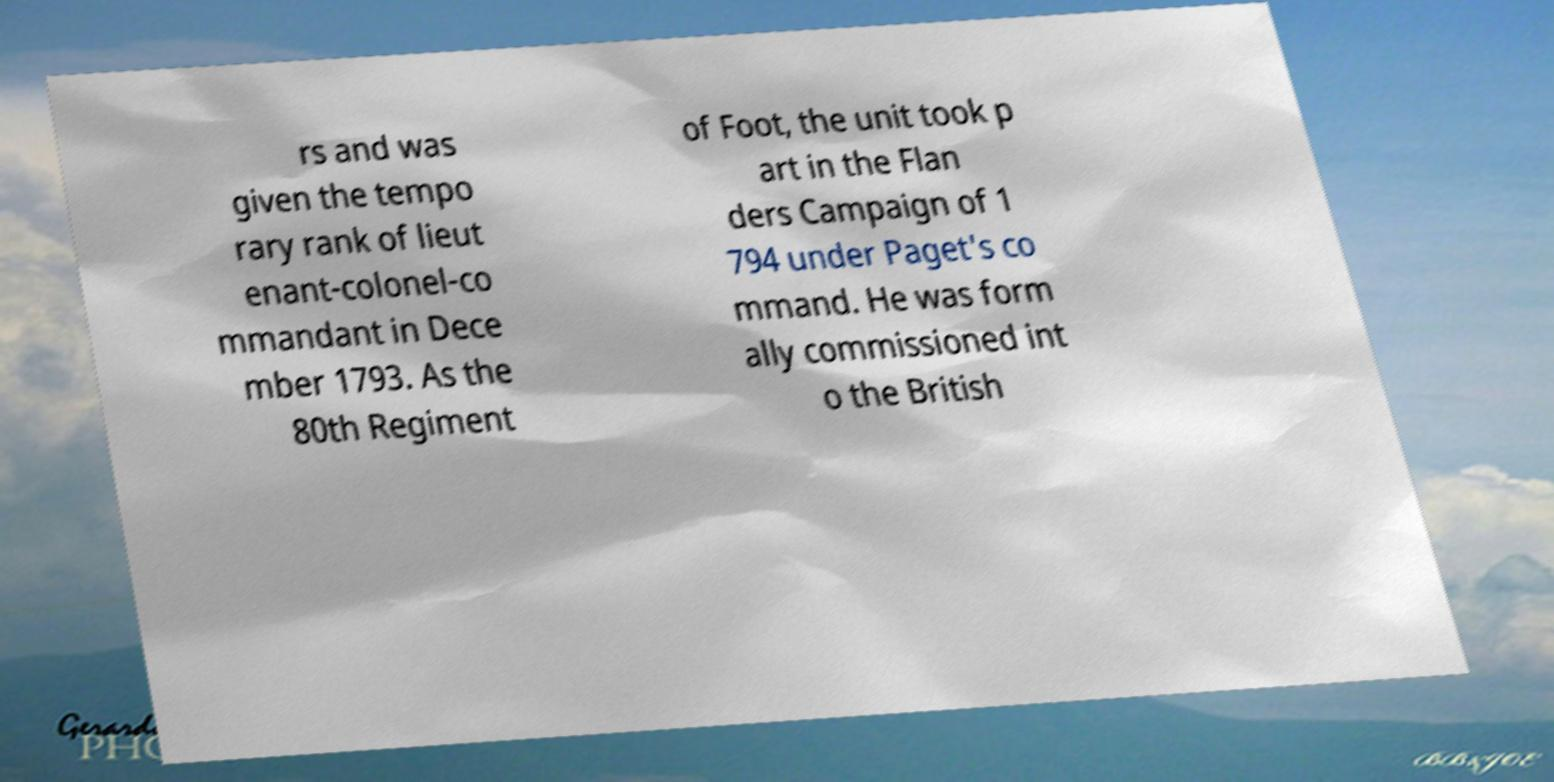Could you extract and type out the text from this image? rs and was given the tempo rary rank of lieut enant-colonel-co mmandant in Dece mber 1793. As the 80th Regiment of Foot, the unit took p art in the Flan ders Campaign of 1 794 under Paget's co mmand. He was form ally commissioned int o the British 